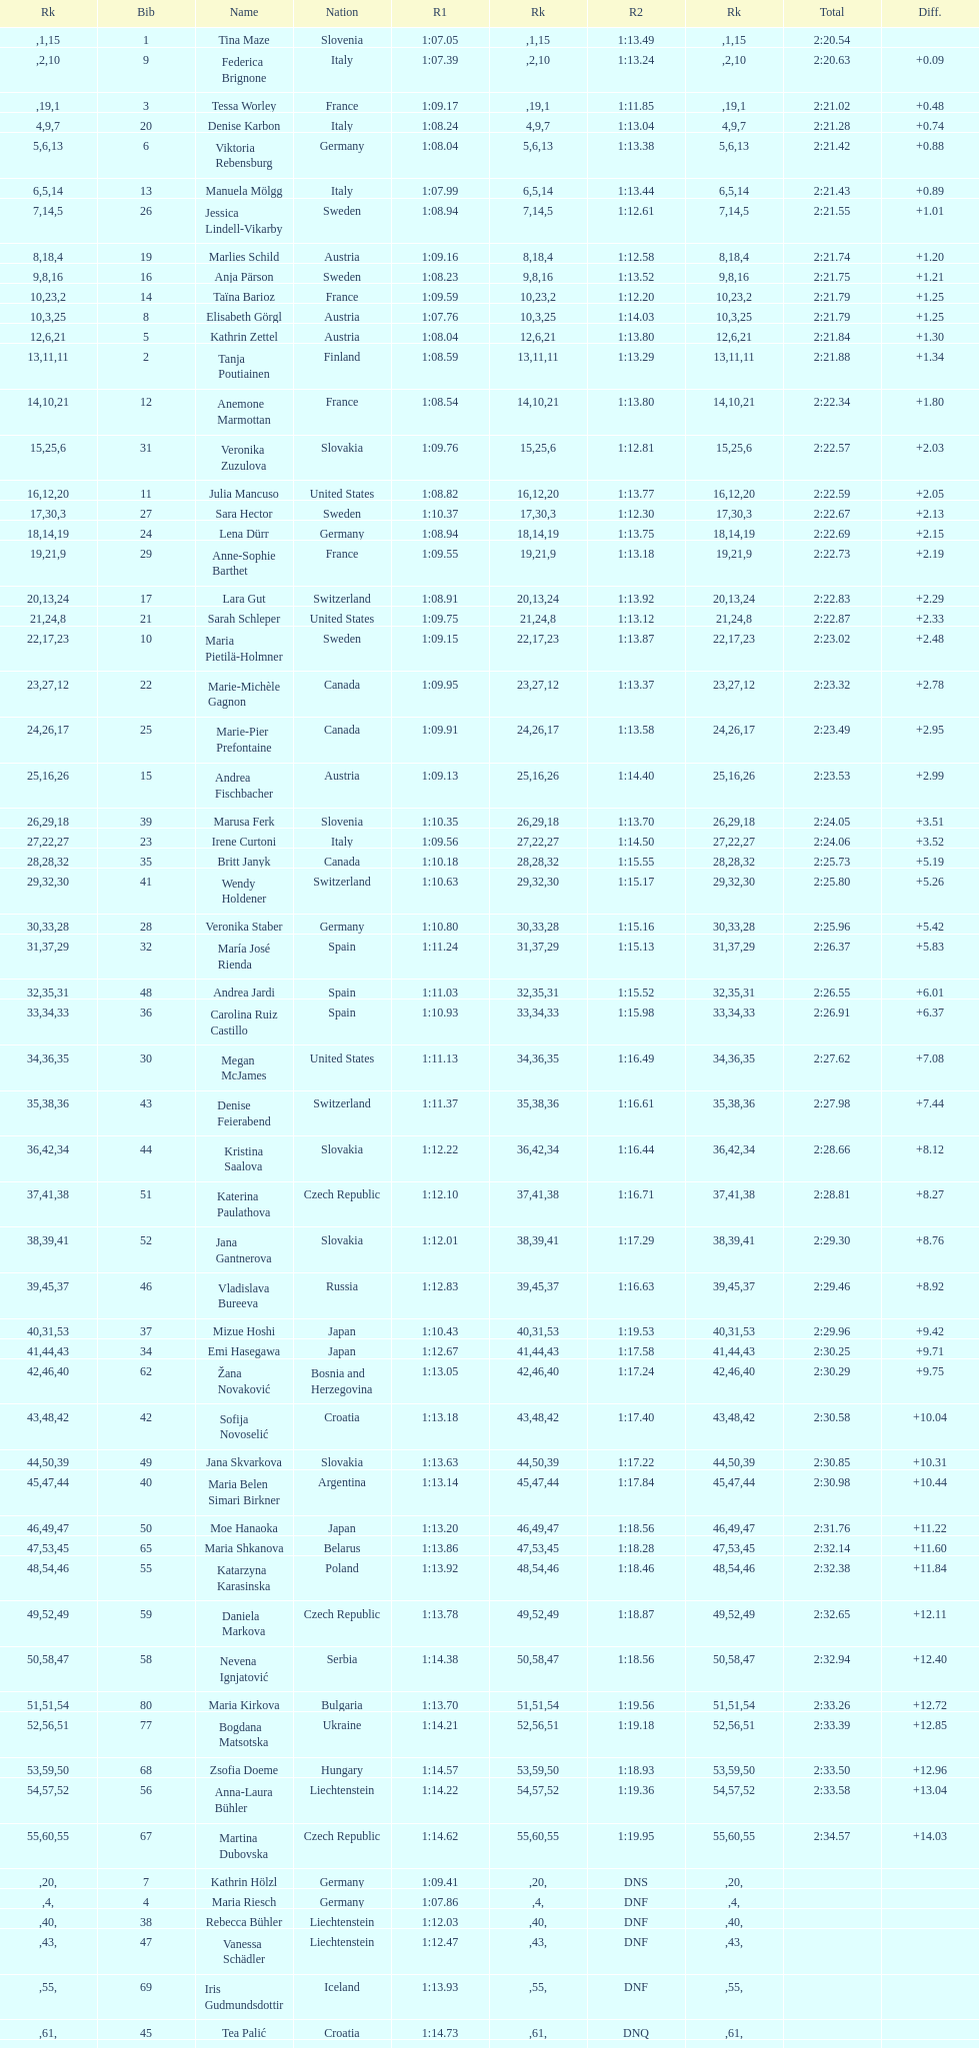What is the most recently ranked country? Czech Republic. 